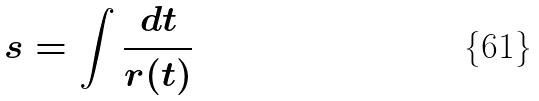Convert formula to latex. <formula><loc_0><loc_0><loc_500><loc_500>s = \int \frac { d t } { r ( t ) }</formula> 